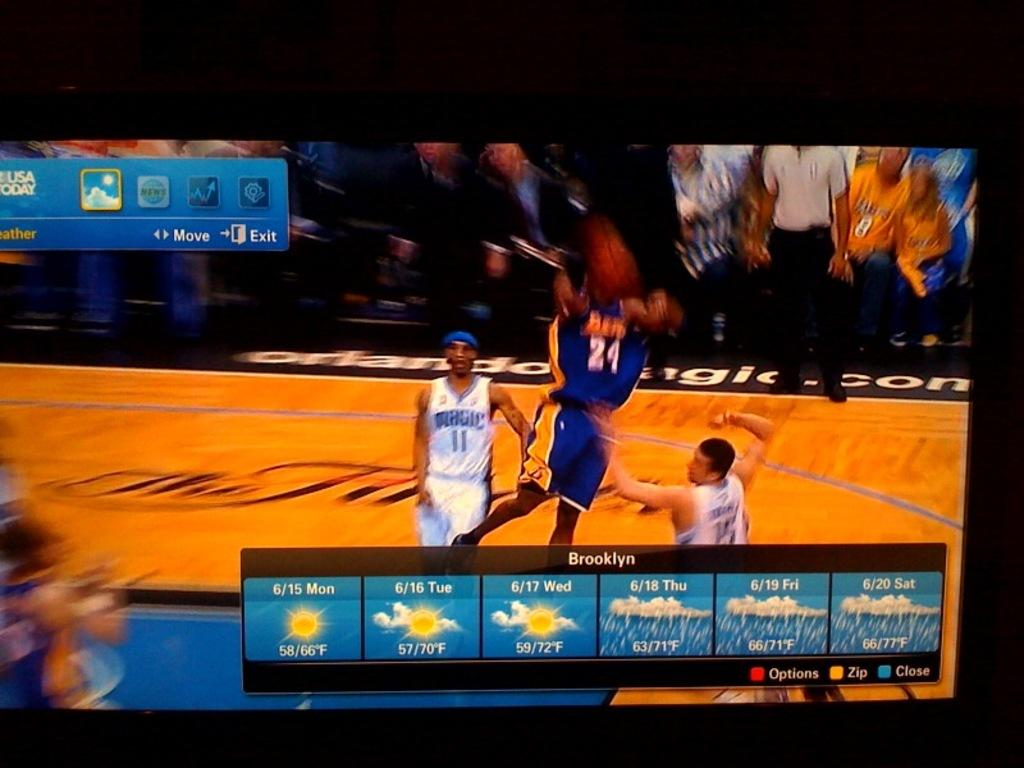<image>
Offer a succinct explanation of the picture presented. A basketball game shown on a tv screen also features the weather report for Brooklyn. 